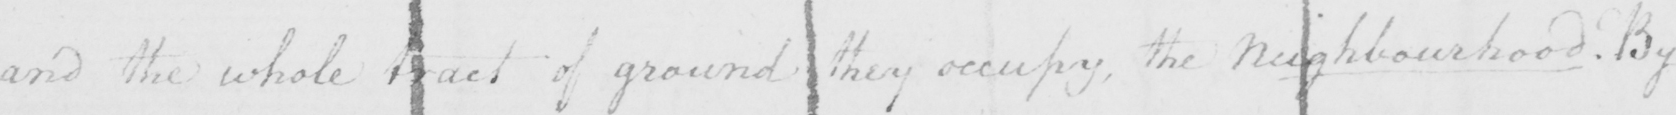What does this handwritten line say? and the whole tract of ground they occupy , the Neighbourhood . By 